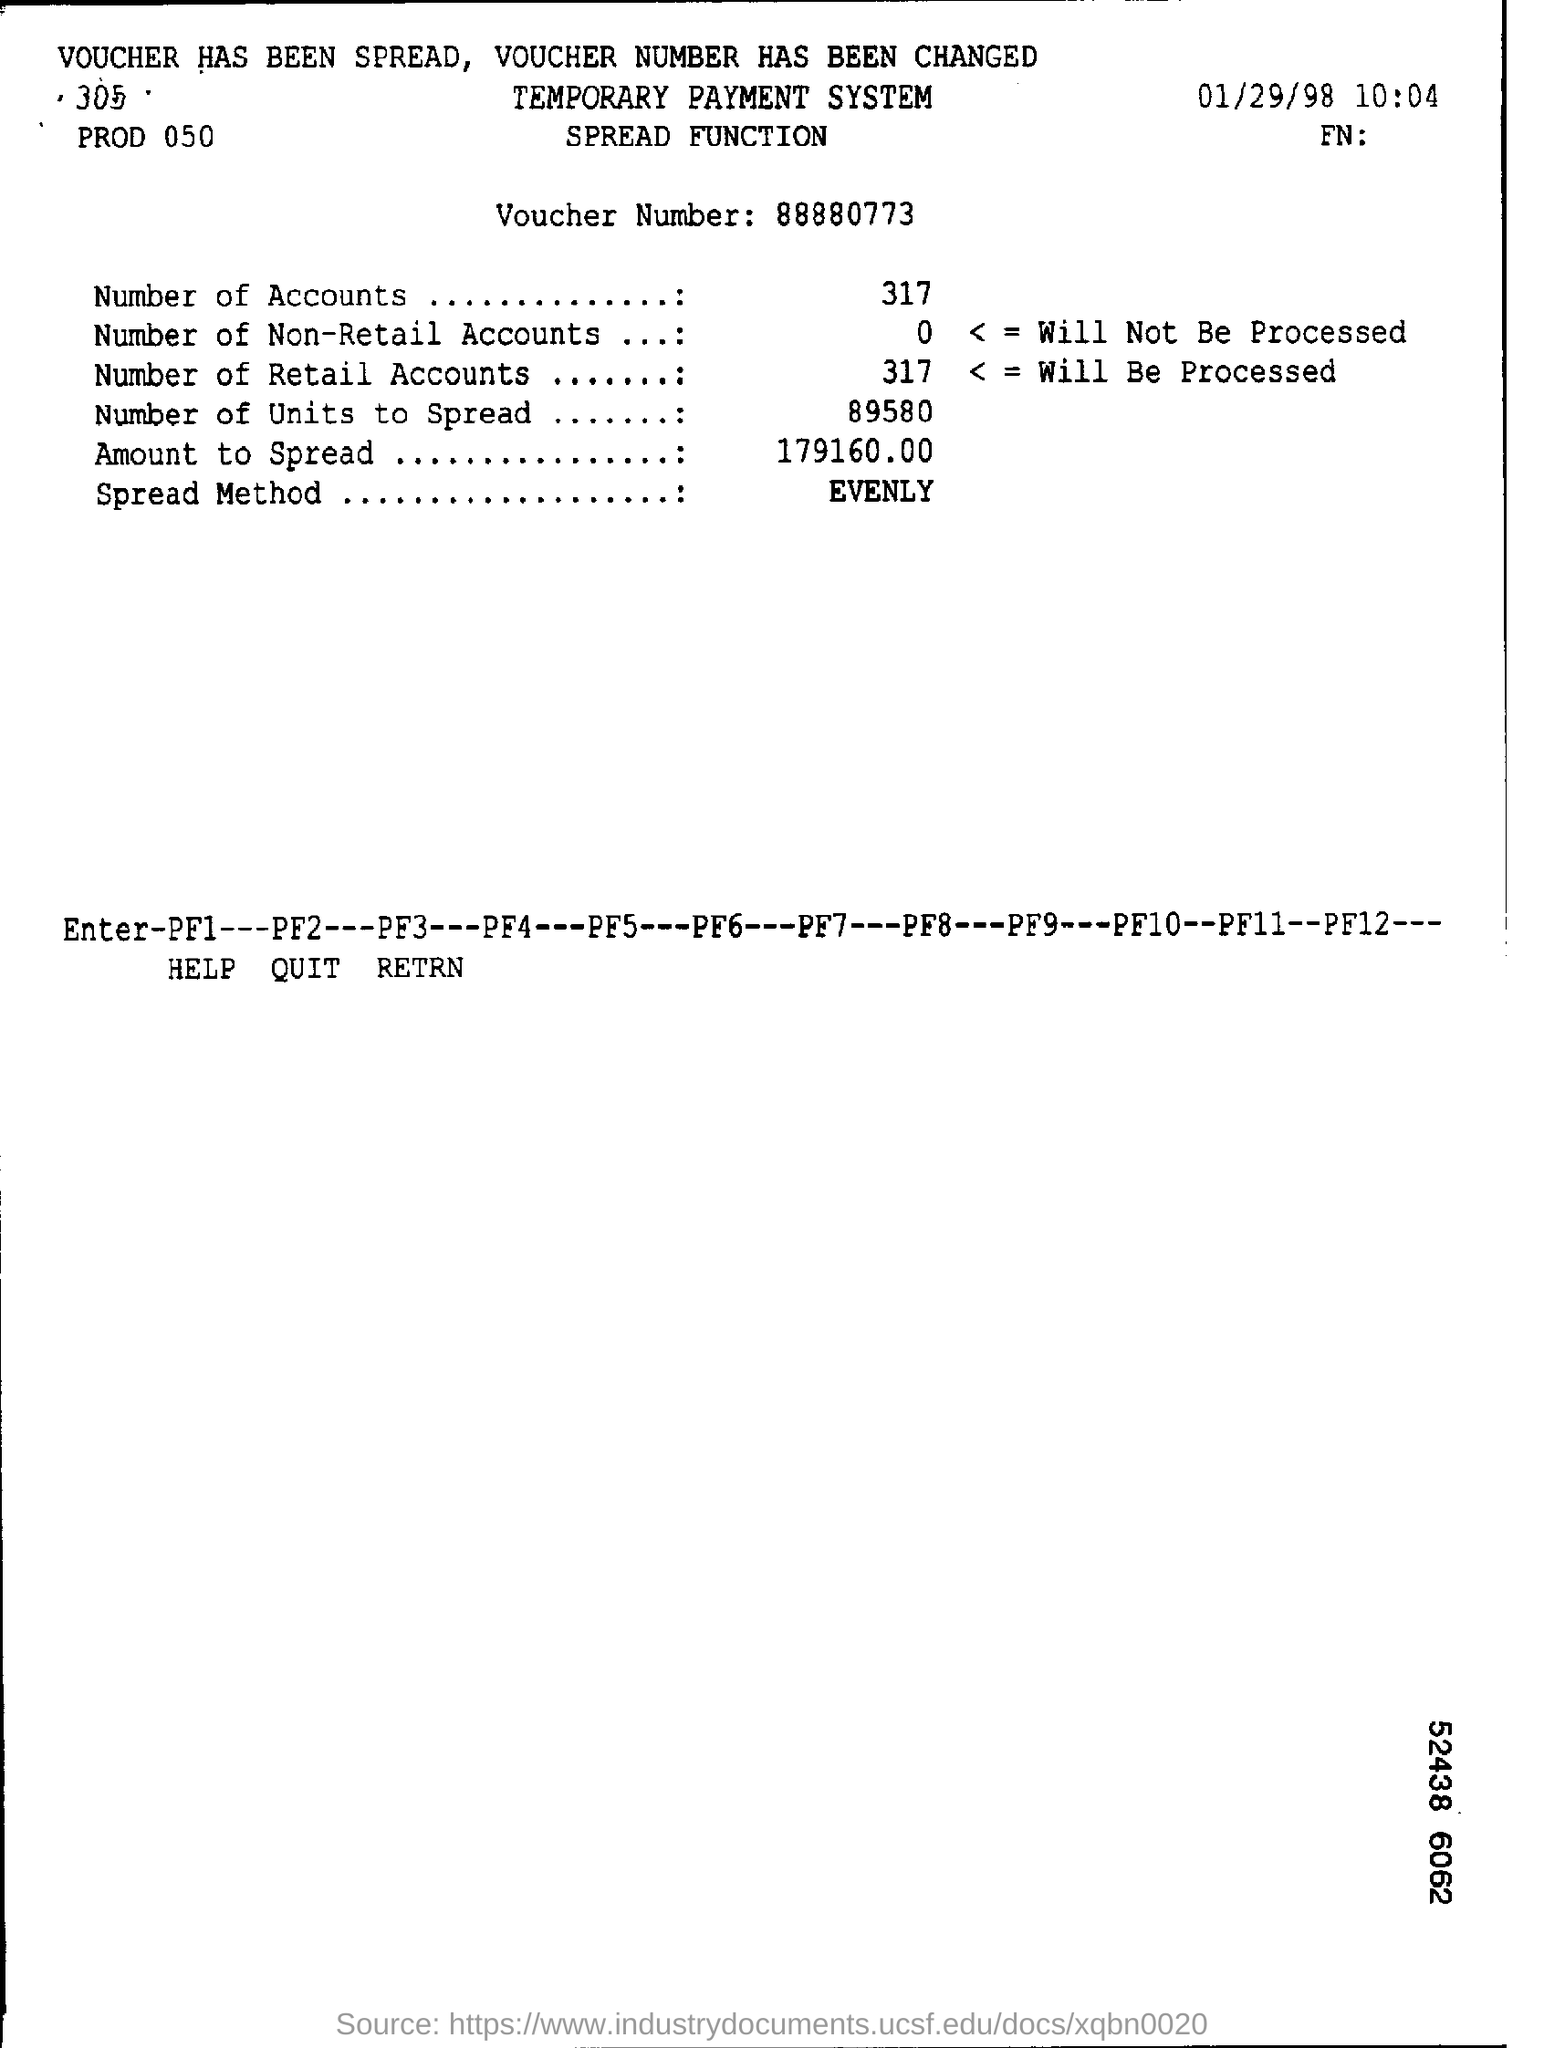Point out several critical features in this image. There are 317 accounts in total. The "Spread Method" is a teaching technique that involves evenly distributing information and activities to ensure that all students have an equal opportunity to learn and understand the material being presented. The number of units to spread is 89,580. The voucher number is 88880773. What is the amount to spread? It is 179,160.00. 